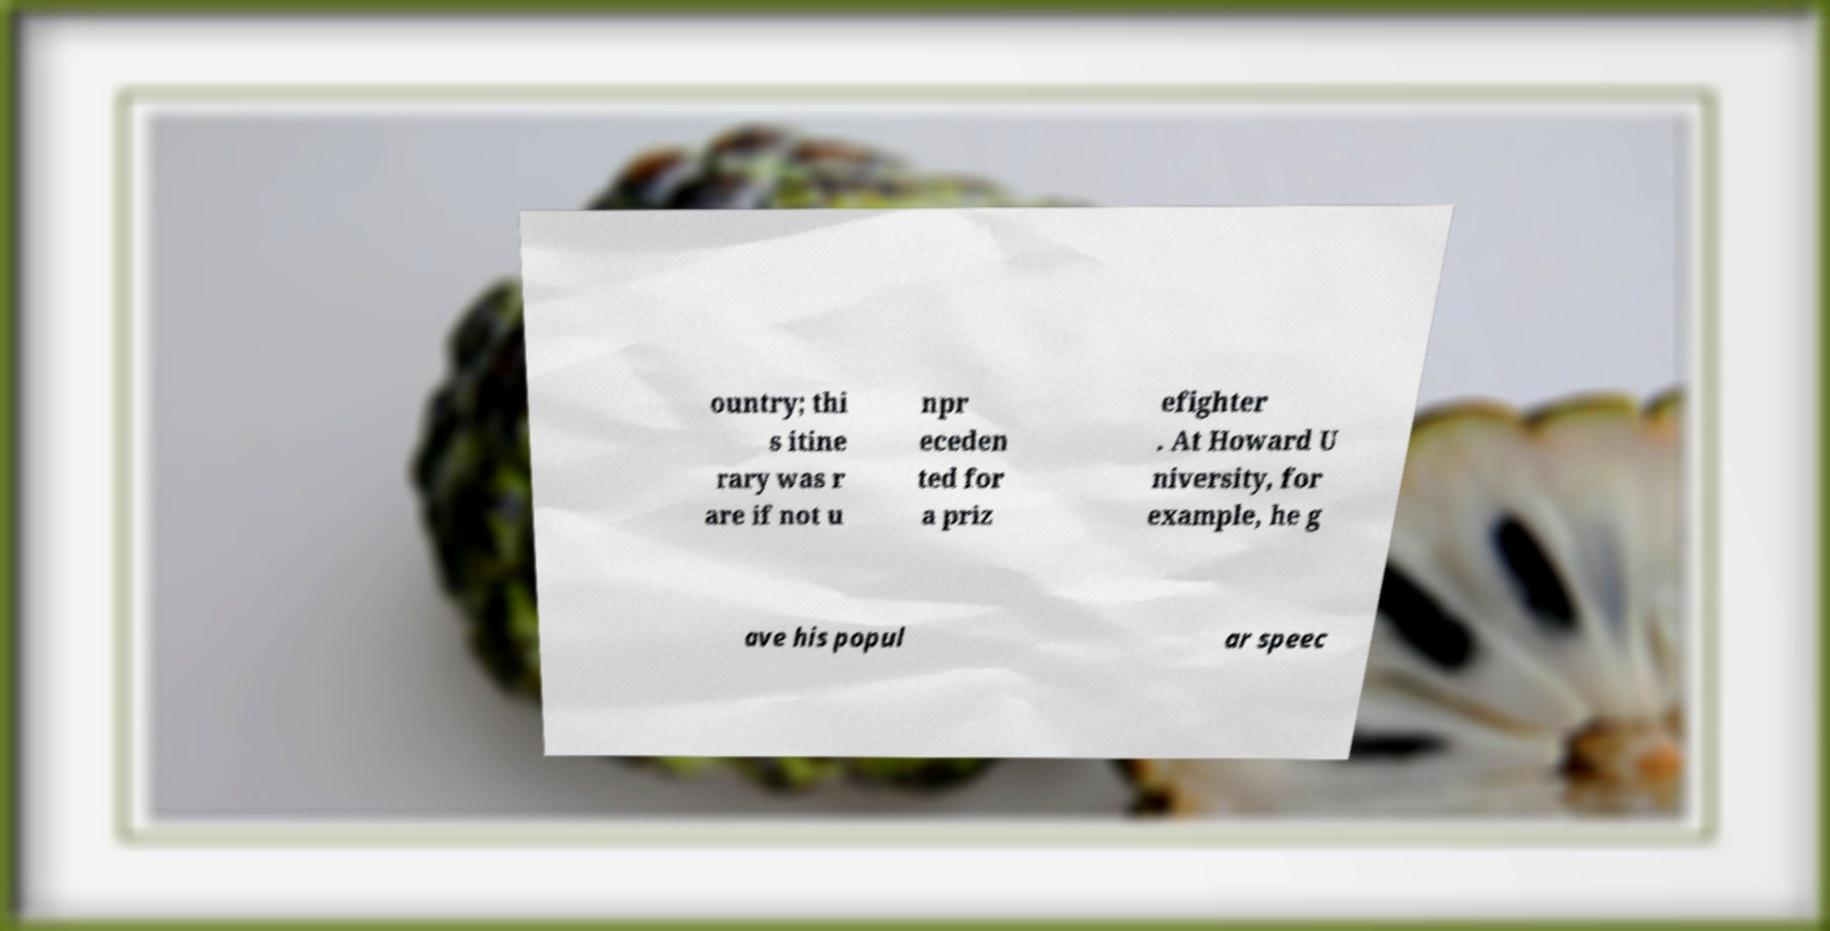I need the written content from this picture converted into text. Can you do that? ountry; thi s itine rary was r are if not u npr eceden ted for a priz efighter . At Howard U niversity, for example, he g ave his popul ar speec 